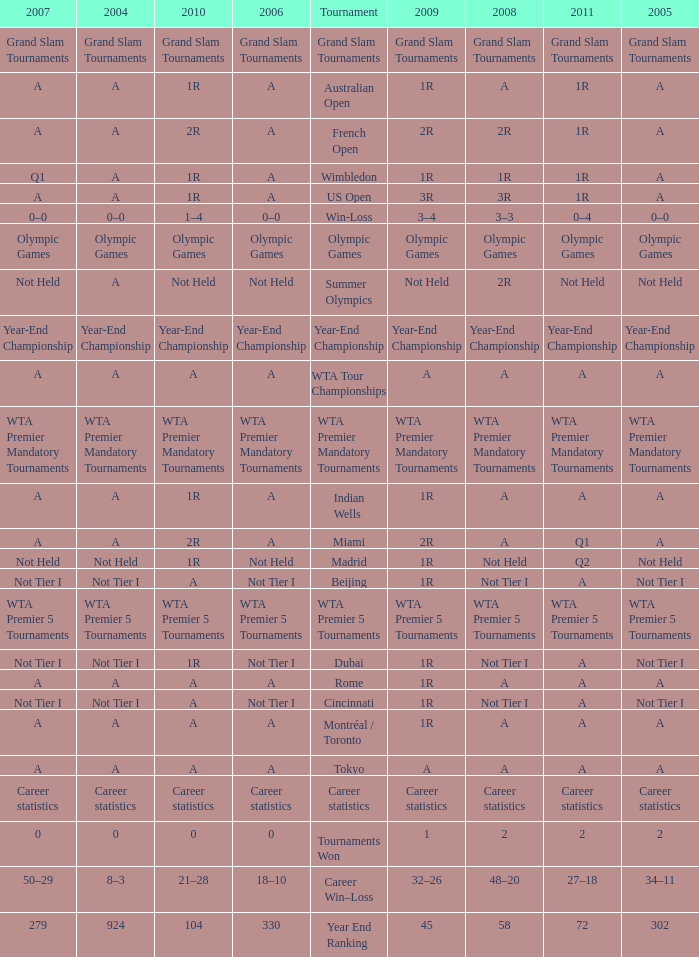What is 2007, when Tournament is "Madrid"? Not Held. 